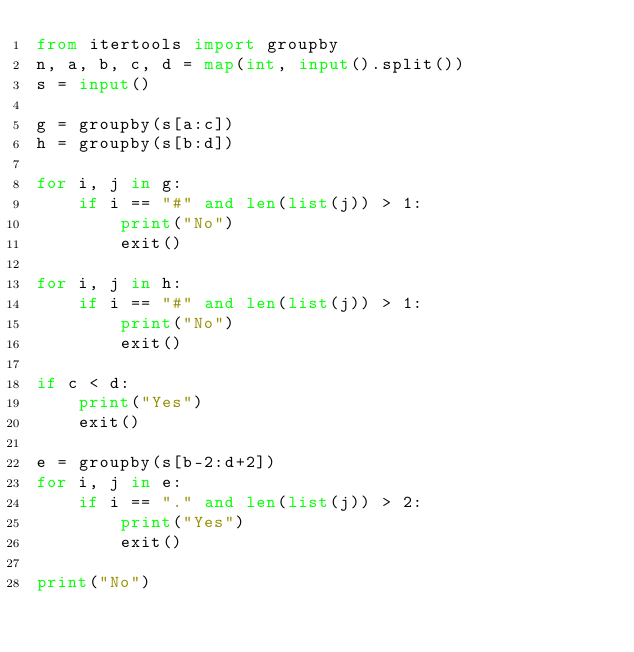Convert code to text. <code><loc_0><loc_0><loc_500><loc_500><_Python_>from itertools import groupby
n, a, b, c, d = map(int, input().split())
s = input()

g = groupby(s[a:c])
h = groupby(s[b:d])

for i, j in g:
    if i == "#" and len(list(j)) > 1:
        print("No")
        exit()

for i, j in h:
    if i == "#" and len(list(j)) > 1:
        print("No")
        exit()

if c < d:
    print("Yes")
    exit()

e = groupby(s[b-2:d+2])
for i, j in e:
    if i == "." and len(list(j)) > 2:
        print("Yes")
        exit()

print("No")</code> 